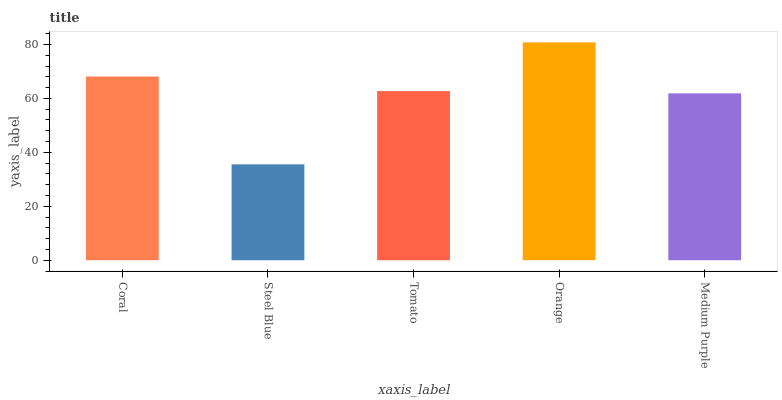Is Steel Blue the minimum?
Answer yes or no. Yes. Is Orange the maximum?
Answer yes or no. Yes. Is Tomato the minimum?
Answer yes or no. No. Is Tomato the maximum?
Answer yes or no. No. Is Tomato greater than Steel Blue?
Answer yes or no. Yes. Is Steel Blue less than Tomato?
Answer yes or no. Yes. Is Steel Blue greater than Tomato?
Answer yes or no. No. Is Tomato less than Steel Blue?
Answer yes or no. No. Is Tomato the high median?
Answer yes or no. Yes. Is Tomato the low median?
Answer yes or no. Yes. Is Coral the high median?
Answer yes or no. No. Is Coral the low median?
Answer yes or no. No. 